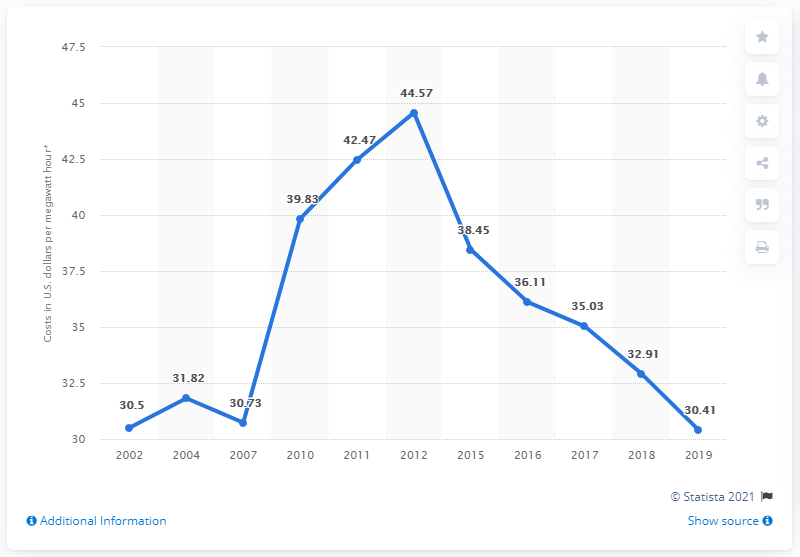Draw attention to some important aspects in this diagram. In the United States, the cost of generating electricity through nuclear power plants is approximately 30.41 cents per megawatt hour. 